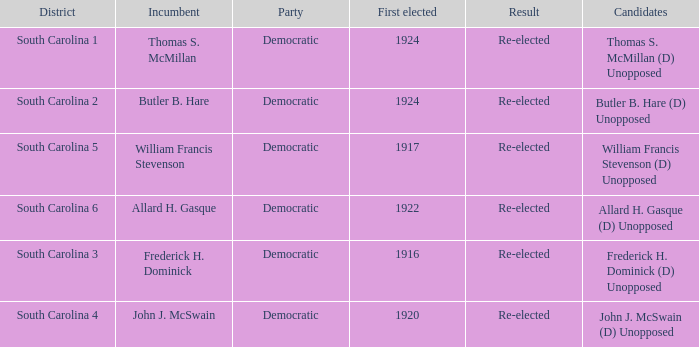What is the total number of results where the district is south carolina 5? 1.0. Can you parse all the data within this table? {'header': ['District', 'Incumbent', 'Party', 'First elected', 'Result', 'Candidates'], 'rows': [['South Carolina 1', 'Thomas S. McMillan', 'Democratic', '1924', 'Re-elected', 'Thomas S. McMillan (D) Unopposed'], ['South Carolina 2', 'Butler B. Hare', 'Democratic', '1924', 'Re-elected', 'Butler B. Hare (D) Unopposed'], ['South Carolina 5', 'William Francis Stevenson', 'Democratic', '1917', 'Re-elected', 'William Francis Stevenson (D) Unopposed'], ['South Carolina 6', 'Allard H. Gasque', 'Democratic', '1922', 'Re-elected', 'Allard H. Gasque (D) Unopposed'], ['South Carolina 3', 'Frederick H. Dominick', 'Democratic', '1916', 'Re-elected', 'Frederick H. Dominick (D) Unopposed'], ['South Carolina 4', 'John J. McSwain', 'Democratic', '1920', 'Re-elected', 'John J. McSwain (D) Unopposed']]} 